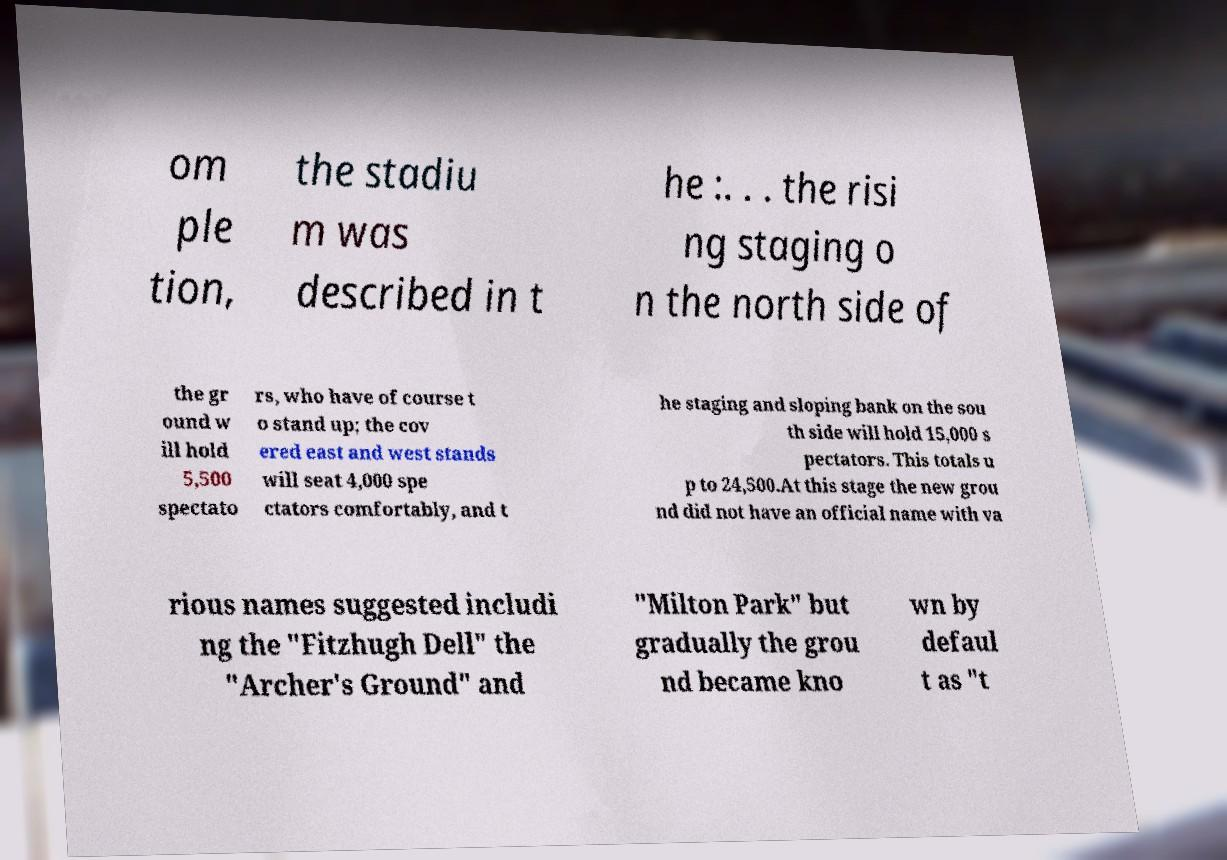There's text embedded in this image that I need extracted. Can you transcribe it verbatim? om ple tion, the stadiu m was described in t he :. . . the risi ng staging o n the north side of the gr ound w ill hold 5,500 spectato rs, who have of course t o stand up; the cov ered east and west stands will seat 4,000 spe ctators comfortably, and t he staging and sloping bank on the sou th side will hold 15,000 s pectators. This totals u p to 24,500.At this stage the new grou nd did not have an official name with va rious names suggested includi ng the "Fitzhugh Dell" the "Archer's Ground" and "Milton Park" but gradually the grou nd became kno wn by defaul t as "t 